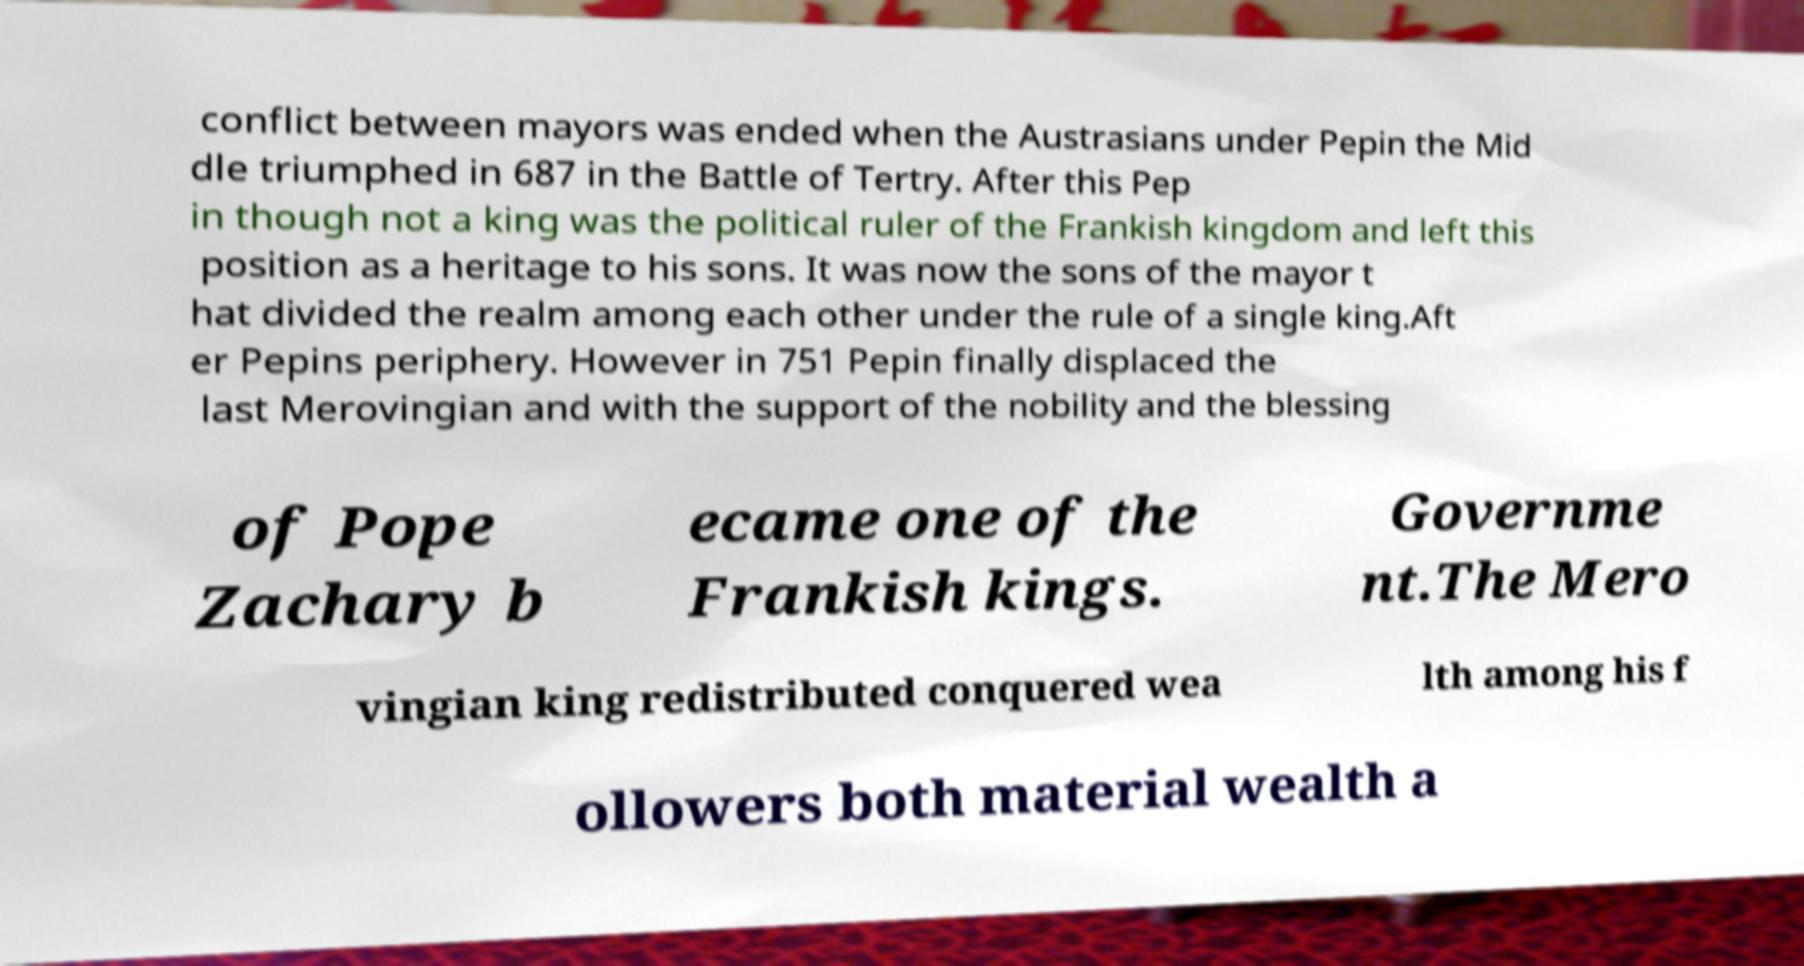Can you accurately transcribe the text from the provided image for me? conflict between mayors was ended when the Austrasians under Pepin the Mid dle triumphed in 687 in the Battle of Tertry. After this Pep in though not a king was the political ruler of the Frankish kingdom and left this position as a heritage to his sons. It was now the sons of the mayor t hat divided the realm among each other under the rule of a single king.Aft er Pepins periphery. However in 751 Pepin finally displaced the last Merovingian and with the support of the nobility and the blessing of Pope Zachary b ecame one of the Frankish kings. Governme nt.The Mero vingian king redistributed conquered wea lth among his f ollowers both material wealth a 